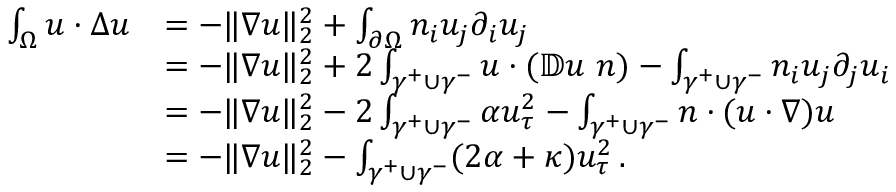Convert formula to latex. <formula><loc_0><loc_0><loc_500><loc_500>\begin{array} { r l } { \int _ { \Omega } u \cdot \Delta u } & { = - \| \nabla u \| _ { 2 } ^ { 2 } + \int _ { \partial \Omega } n _ { i } u _ { j } \partial _ { i } u _ { j } } \\ & { = - \| \nabla u \| _ { 2 } ^ { 2 } + 2 \int _ { \gamma ^ { + } \cup \gamma ^ { - } } u \cdot ( \mathbb { D } u \ n ) - \int _ { \gamma ^ { + } \cup \gamma ^ { - } } n _ { i } u _ { j } \partial _ { j } u _ { i } } \\ & { = - \| \nabla u \| _ { 2 } ^ { 2 } - 2 \int _ { \gamma ^ { + } \cup \gamma ^ { - } } \alpha u _ { \tau } ^ { 2 } - \int _ { \gamma ^ { + } \cup \gamma ^ { - } } n \cdot ( u \cdot \nabla ) u } \\ & { = - \| \nabla u \| _ { 2 } ^ { 2 } - \int _ { \gamma ^ { + } \cup \gamma ^ { - } } ( 2 \alpha + \kappa ) u _ { \tau } ^ { 2 } \, . } \end{array}</formula> 